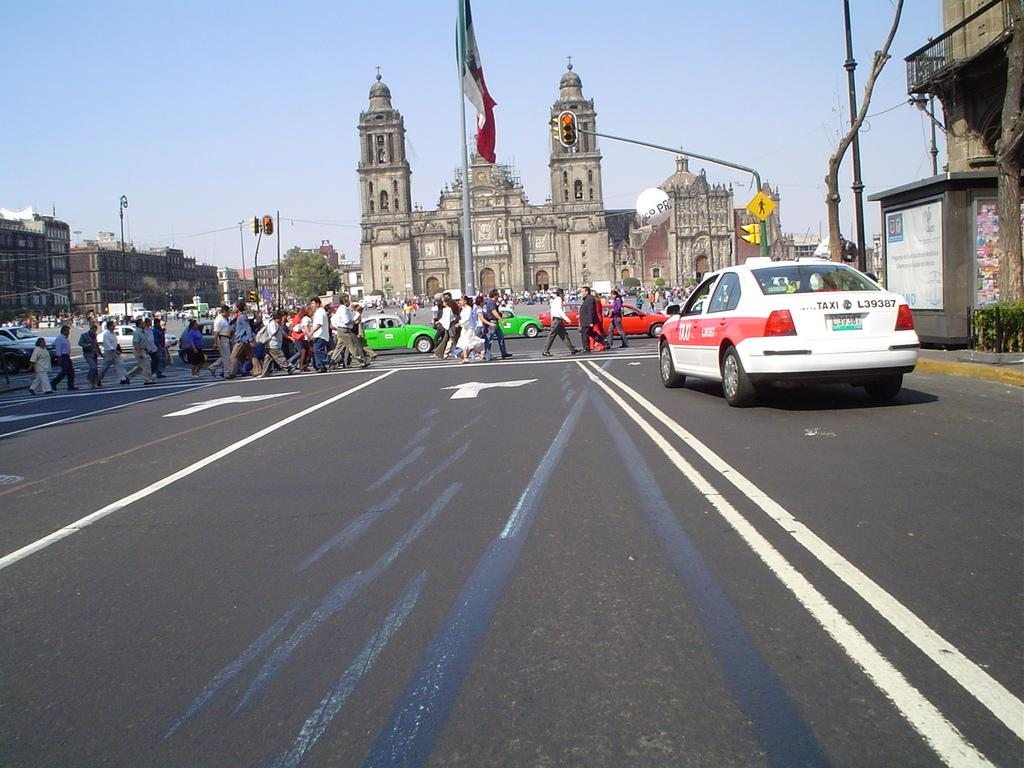<image>
Summarize the visual content of the image. a street view of people crossing a crosswalk in front of taxi l39387 